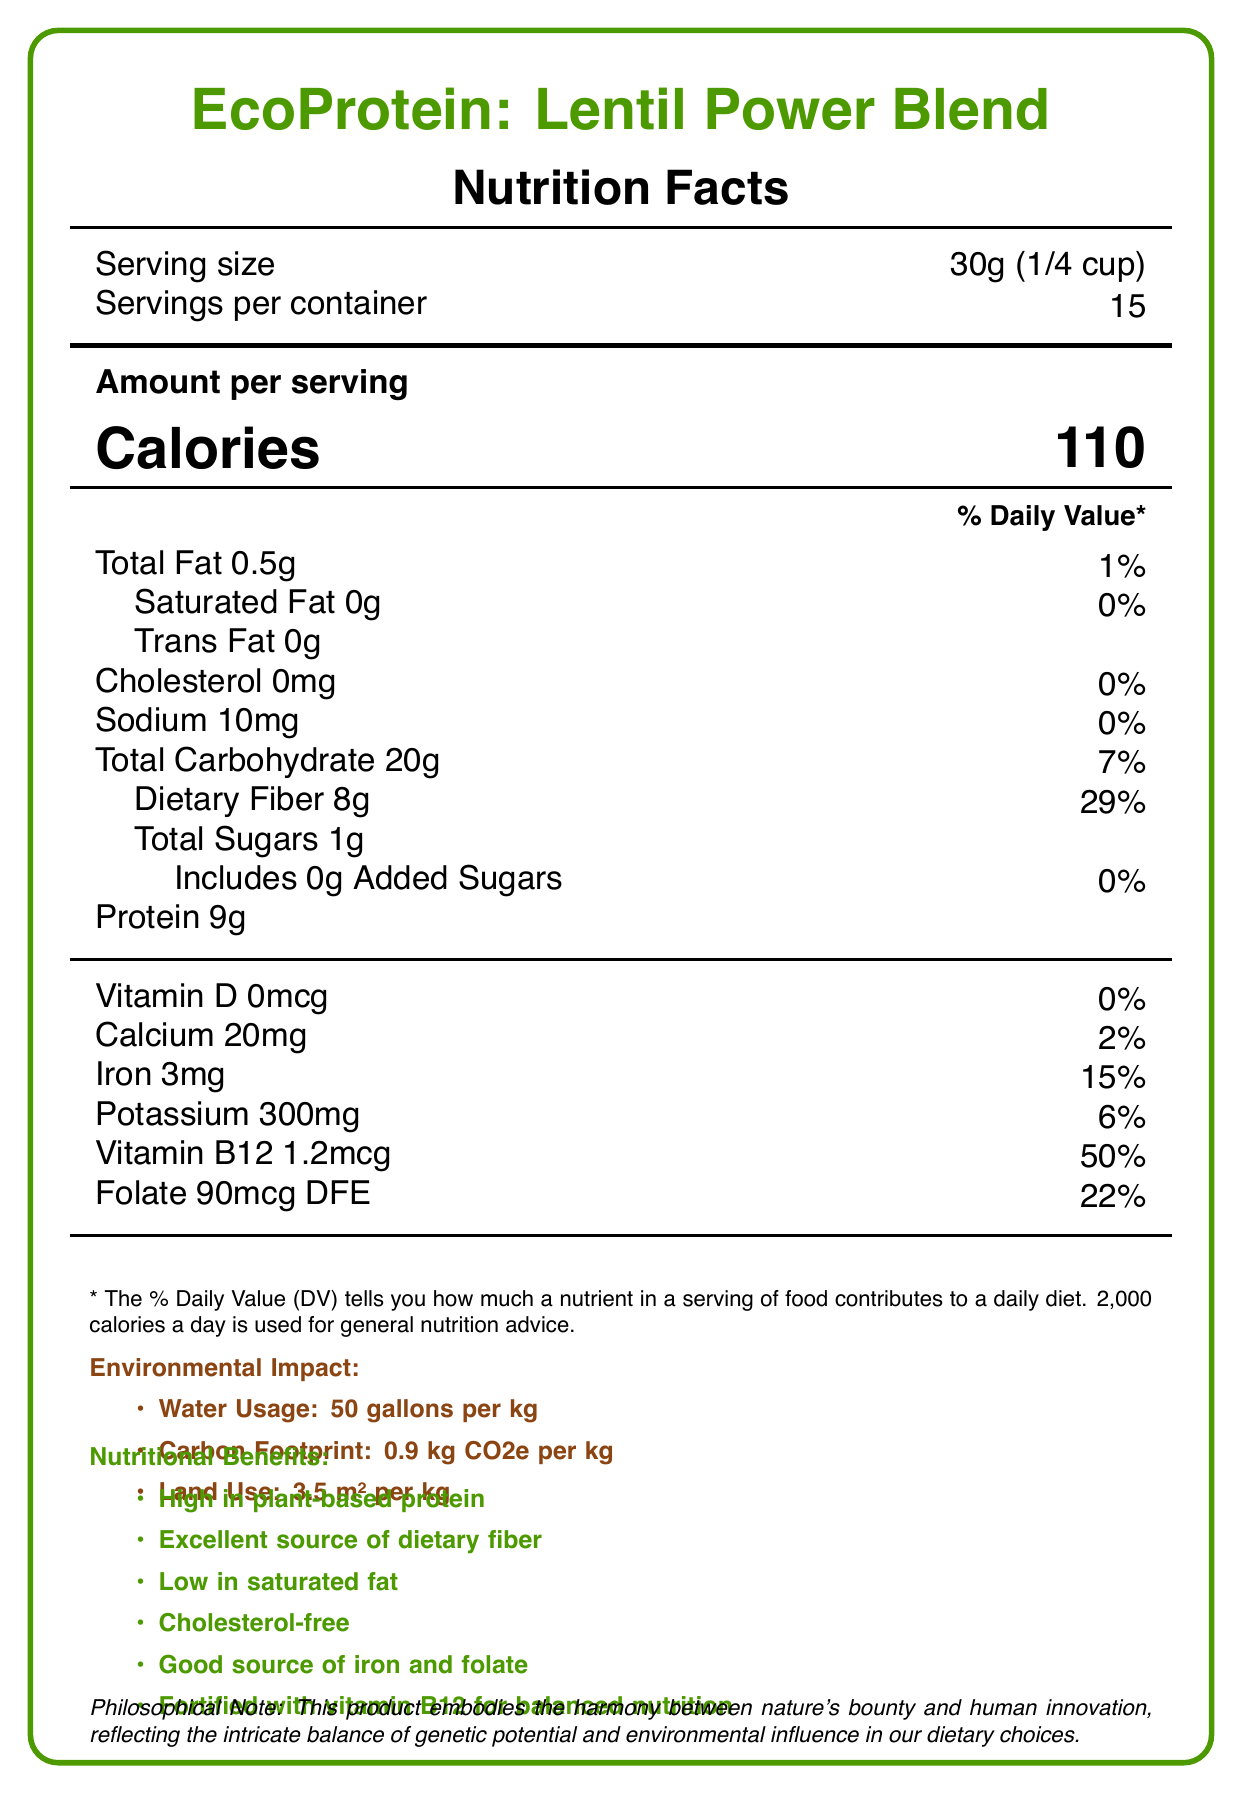what is the serving size? The serving size is listed at the top of the document under the "Serving size" section.
Answer: 30g (1/4 cup) how many calories are in one serving? The amount per serving lists calories as 110.
Answer: 110 what percentage of the daily value for dietary fiber does one serving provide? The document states that one serving provides 8g of dietary fiber, which is 29% of the daily value.
Answer: 29% what is the protein content per serving? The protein content per serving is listed as 9g.
Answer: 9g how much iron does one serving contain in mg? The document lists iron content as 3mg for each serving.
Answer: 3mg how many servings are there per container? The servings per container are listed as 15 at the top of the document.
Answer: 15 which vitamin is fortified in this product and contributes 50% of the daily value? A. Vitamin D B. Vitamin B12 C. Folate Vitamin B12 provides 50% of the daily value per serving as indicated in the document.
Answer: B. Vitamin B12 which of the following is NOT a listed nutritional benefit of EcoProtein: Lentil Power Blend? 1. High in plant-based protein 2. Excellent source of dietary fiber 3. High in cholesterol 4. Good source of iron and folate The product is actually cholesterol-free. The incorrect option among the nutritional benefits is "High in cholesterol."
Answer: 3. High in cholesterol is this product high in saturated fat content? The document lists 0g saturated fat with 0% daily value, indicating it is low in saturated fat content.
Answer: No does this product contain any added sugars? The document indicates that the product includes 0g of added sugars.
Answer: No summarize the main idea of the document. The document provides detailed nutritional information, highlights the environmental impact and lists the nutritional benefits of the EcoProtein: Lentil Power Blend, along with a philosophical note about the balance between nature and human innovation.
Answer: The EcoProtein: Lentil Power Blend is a plant-based protein source that provides various nutritional benefits such as high protein, excellent dietary fiber, low saturated fat, and essential vitamins and minerals. It has a low environmental impact with minimal water usage, carbon footprint, and land use. what is the carbon footprint of the product? The environmental impact section states the carbon footprint as 0.9 kg CO2e per kg.
Answer: 0.9 kg CO2e per kg what ingredients are used in the EcoProtein: Lentil Power Blend? The ingredient list mentions all these components.
Answer: Organic lentil protein concentrate, organic pea protein, organic brown rice protein, natural flavors, organic stevia leaf extract, vitamin and mineral blend (ferrous sulfate, folic acid, cyanocobalamin). where are the lentils for this product sourced from? The document does not specify the exact sourcing locations of the lentils, only that they are from regenerative farms.
Answer: Cannot be determined what is the potassium content per serving in terms of percentage daily value? The document states that the potassium content per serving is 300mg, which equals 6% daily value.
Answer: 6% 